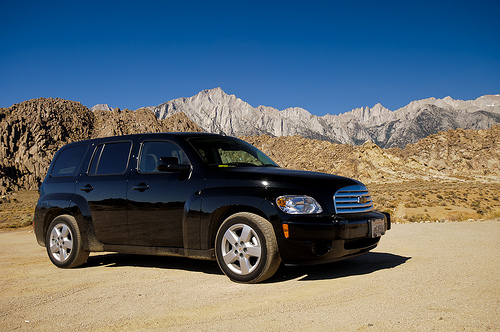<image>
Is the wheel in front of the car? Yes. The wheel is positioned in front of the car, appearing closer to the camera viewpoint. 